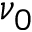<formula> <loc_0><loc_0><loc_500><loc_500>\nu _ { 0 }</formula> 